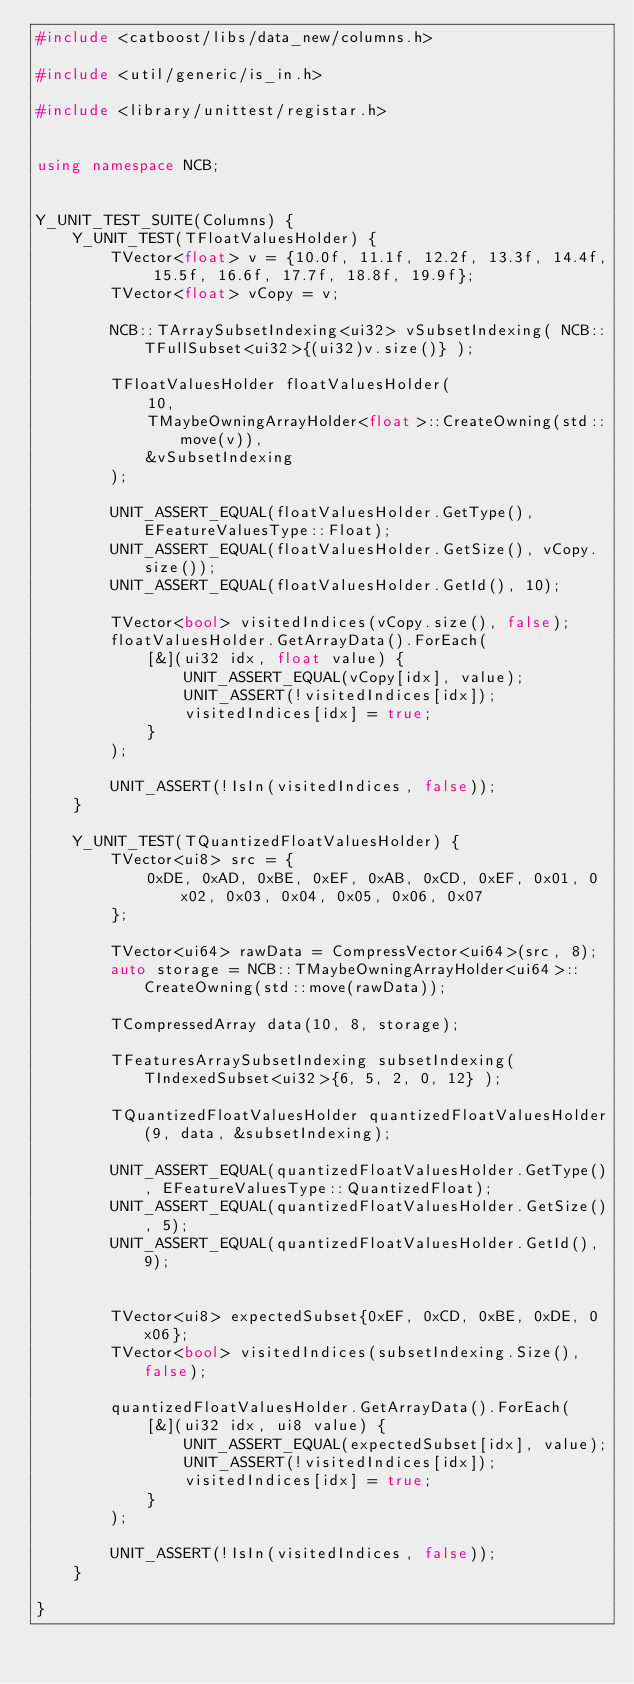Convert code to text. <code><loc_0><loc_0><loc_500><loc_500><_C++_>#include <catboost/libs/data_new/columns.h>

#include <util/generic/is_in.h>

#include <library/unittest/registar.h>


using namespace NCB;


Y_UNIT_TEST_SUITE(Columns) {
    Y_UNIT_TEST(TFloatValuesHolder) {
        TVector<float> v = {10.0f, 11.1f, 12.2f, 13.3f, 14.4f, 15.5f, 16.6f, 17.7f, 18.8f, 19.9f};
        TVector<float> vCopy = v;

        NCB::TArraySubsetIndexing<ui32> vSubsetIndexing( NCB::TFullSubset<ui32>{(ui32)v.size()} );

        TFloatValuesHolder floatValuesHolder(
            10,
            TMaybeOwningArrayHolder<float>::CreateOwning(std::move(v)),
            &vSubsetIndexing
        );

        UNIT_ASSERT_EQUAL(floatValuesHolder.GetType(), EFeatureValuesType::Float);
        UNIT_ASSERT_EQUAL(floatValuesHolder.GetSize(), vCopy.size());
        UNIT_ASSERT_EQUAL(floatValuesHolder.GetId(), 10);

        TVector<bool> visitedIndices(vCopy.size(), false);
        floatValuesHolder.GetArrayData().ForEach(
            [&](ui32 idx, float value) {
                UNIT_ASSERT_EQUAL(vCopy[idx], value);
                UNIT_ASSERT(!visitedIndices[idx]);
                visitedIndices[idx] = true;
            }
        );

        UNIT_ASSERT(!IsIn(visitedIndices, false));
    }

    Y_UNIT_TEST(TQuantizedFloatValuesHolder) {
        TVector<ui8> src = {
            0xDE, 0xAD, 0xBE, 0xEF, 0xAB, 0xCD, 0xEF, 0x01, 0x02, 0x03, 0x04, 0x05, 0x06, 0x07
        };

        TVector<ui64> rawData = CompressVector<ui64>(src, 8);
        auto storage = NCB::TMaybeOwningArrayHolder<ui64>::CreateOwning(std::move(rawData));

        TCompressedArray data(10, 8, storage);

        TFeaturesArraySubsetIndexing subsetIndexing( TIndexedSubset<ui32>{6, 5, 2, 0, 12} );

        TQuantizedFloatValuesHolder quantizedFloatValuesHolder(9, data, &subsetIndexing);

        UNIT_ASSERT_EQUAL(quantizedFloatValuesHolder.GetType(), EFeatureValuesType::QuantizedFloat);
        UNIT_ASSERT_EQUAL(quantizedFloatValuesHolder.GetSize(), 5);
        UNIT_ASSERT_EQUAL(quantizedFloatValuesHolder.GetId(), 9);


        TVector<ui8> expectedSubset{0xEF, 0xCD, 0xBE, 0xDE, 0x06};
        TVector<bool> visitedIndices(subsetIndexing.Size(), false);

        quantizedFloatValuesHolder.GetArrayData().ForEach(
            [&](ui32 idx, ui8 value) {
                UNIT_ASSERT_EQUAL(expectedSubset[idx], value);
                UNIT_ASSERT(!visitedIndices[idx]);
                visitedIndices[idx] = true;
            }
        );

        UNIT_ASSERT(!IsIn(visitedIndices, false));
    }

}
</code> 